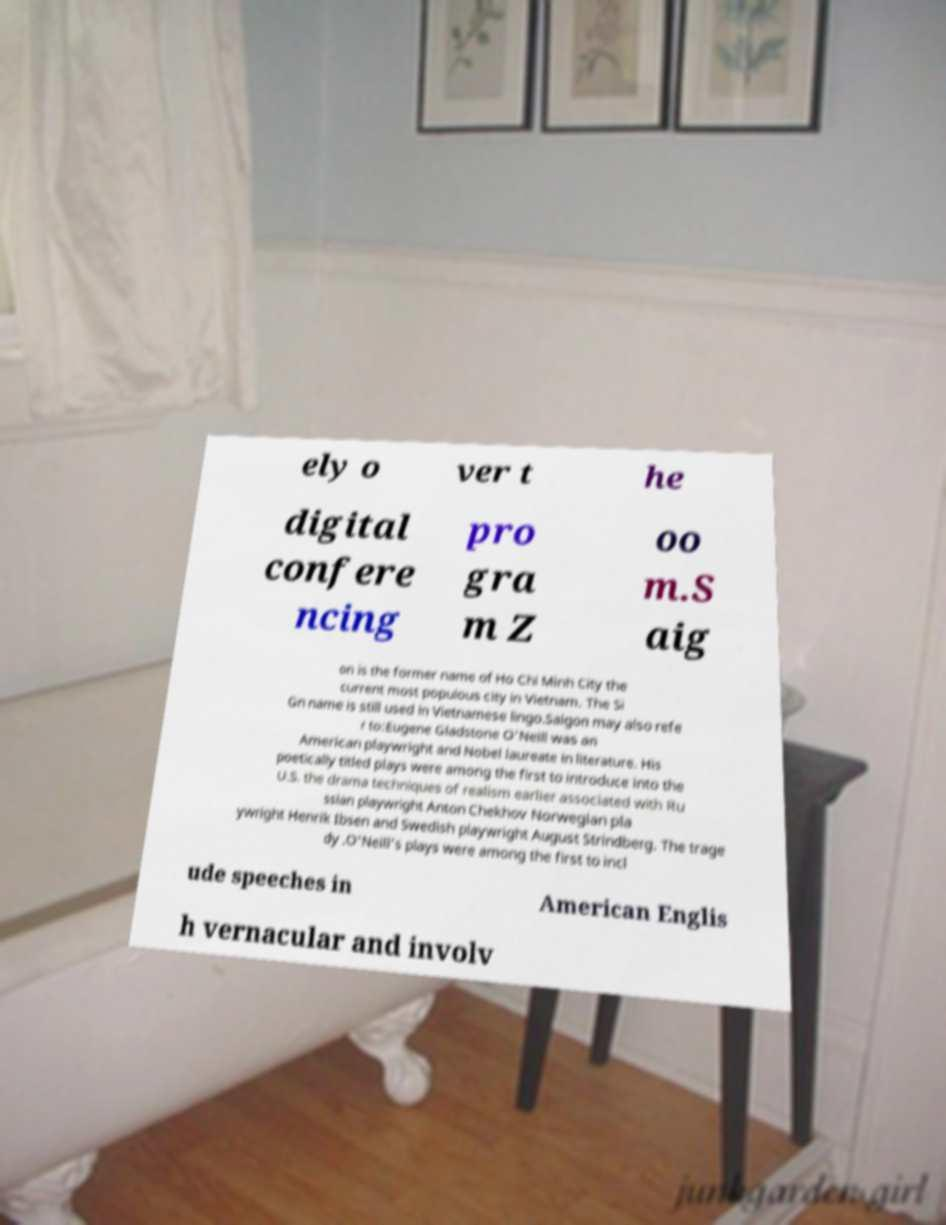Can you read and provide the text displayed in the image?This photo seems to have some interesting text. Can you extract and type it out for me? ely o ver t he digital confere ncing pro gra m Z oo m.S aig on is the former name of Ho Chi Minh City the current most populous city in Vietnam. The Si Gn name is still used in Vietnamese lingo.Saigon may also refe r to:Eugene Gladstone O'Neill was an American playwright and Nobel laureate in literature. His poetically titled plays were among the first to introduce into the U.S. the drama techniques of realism earlier associated with Ru ssian playwright Anton Chekhov Norwegian pla ywright Henrik Ibsen and Swedish playwright August Strindberg. The trage dy .O'Neill's plays were among the first to incl ude speeches in American Englis h vernacular and involv 